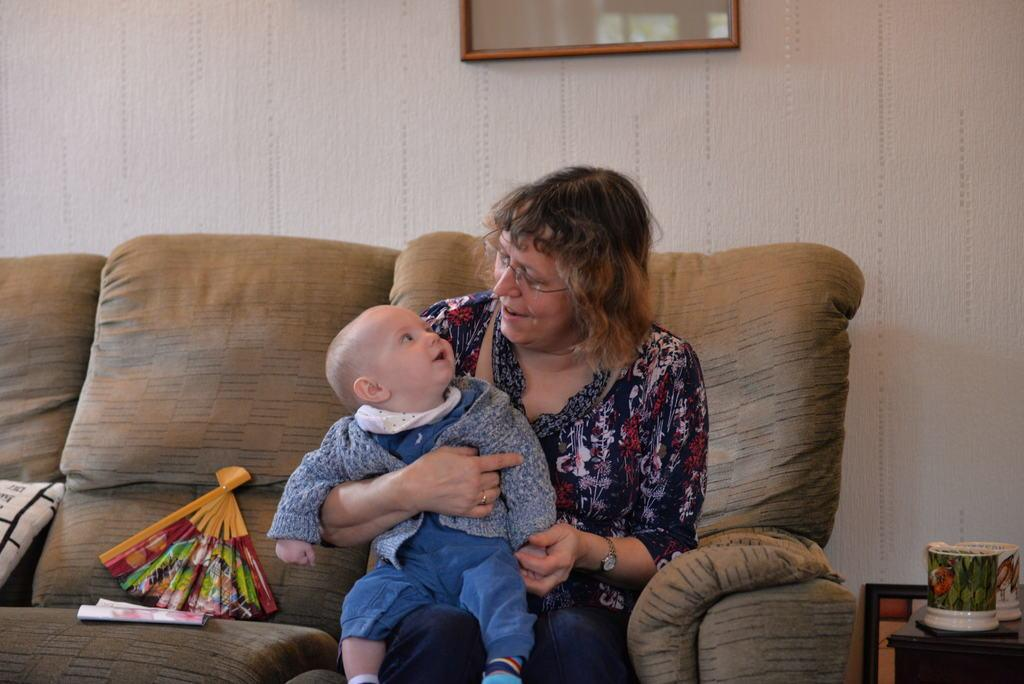What is the woman in the image doing? The woman is sitting on the sofa and holding a child. What can be seen on the wall in the image? There is a photo frame on the wall. What object is visible in the image that might be used for holding liquids? There is a cup in the image. What type of trucks can be seen driving through the room in the image? There are no trucks visible in the image; it features a woman sitting on a sofa holding a child, a photo frame on the wall, and a cup. What shape is the hope depicted in the image? The concept of hope is not a tangible object that can be depicted in the image, so it cannot be described in terms of shape. 